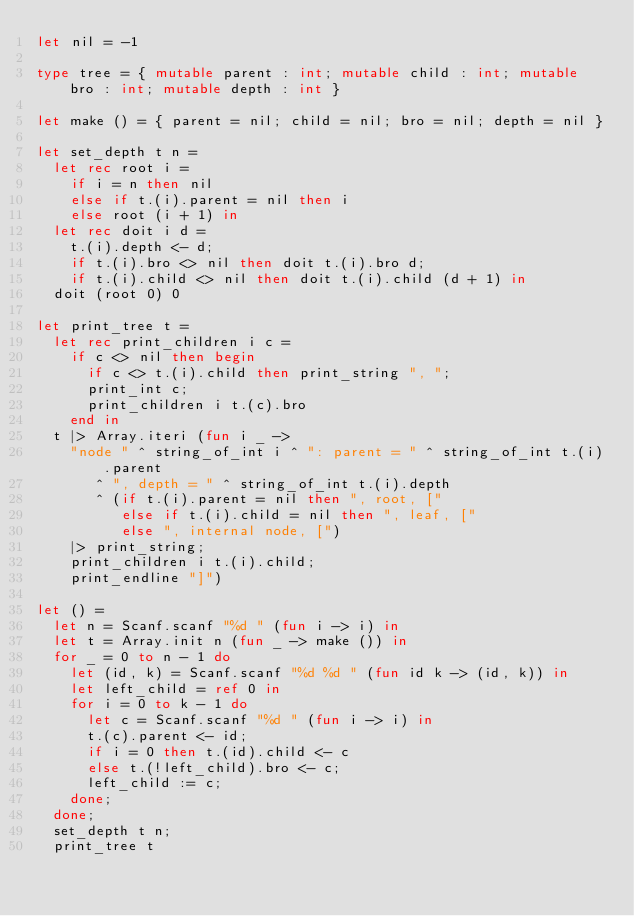Convert code to text. <code><loc_0><loc_0><loc_500><loc_500><_OCaml_>let nil = -1

type tree = { mutable parent : int; mutable child : int; mutable bro : int; mutable depth : int }

let make () = { parent = nil; child = nil; bro = nil; depth = nil }

let set_depth t n =
  let rec root i =
    if i = n then nil
    else if t.(i).parent = nil then i
    else root (i + 1) in
  let rec doit i d =
    t.(i).depth <- d;
    if t.(i).bro <> nil then doit t.(i).bro d;
    if t.(i).child <> nil then doit t.(i).child (d + 1) in
  doit (root 0) 0

let print_tree t =
  let rec print_children i c =
    if c <> nil then begin
      if c <> t.(i).child then print_string ", ";
      print_int c;
      print_children i t.(c).bro
    end in
  t |> Array.iteri (fun i _ ->
    "node " ^ string_of_int i ^ ": parent = " ^ string_of_int t.(i).parent
       ^ ", depth = " ^ string_of_int t.(i).depth
       ^ (if t.(i).parent = nil then ", root, ["
          else if t.(i).child = nil then ", leaf, ["
          else ", internal node, [")
    |> print_string;
    print_children i t.(i).child;
    print_endline "]")

let () =
  let n = Scanf.scanf "%d " (fun i -> i) in
  let t = Array.init n (fun _ -> make ()) in
  for _ = 0 to n - 1 do
    let (id, k) = Scanf.scanf "%d %d " (fun id k -> (id, k)) in
    let left_child = ref 0 in
    for i = 0 to k - 1 do
      let c = Scanf.scanf "%d " (fun i -> i) in
      t.(c).parent <- id;
      if i = 0 then t.(id).child <- c
      else t.(!left_child).bro <- c;
      left_child := c;
    done;
  done;
  set_depth t n;
  print_tree t</code> 